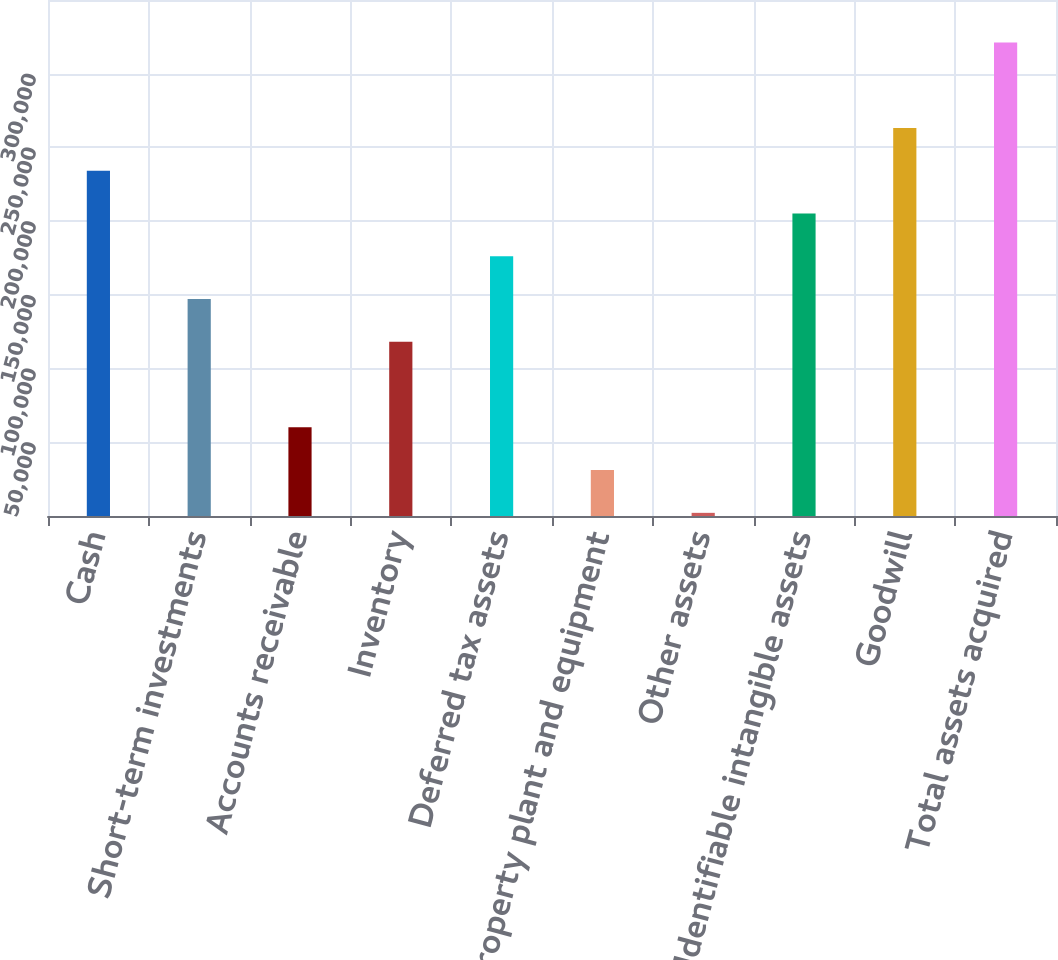Convert chart. <chart><loc_0><loc_0><loc_500><loc_500><bar_chart><fcel>Cash<fcel>Short-term investments<fcel>Accounts receivable<fcel>Inventory<fcel>Deferred tax assets<fcel>Property plant and equipment<fcel>Other assets<fcel>Identifiable intangible assets<fcel>Goodwill<fcel>Total assets acquired<nl><fcel>234177<fcel>147162<fcel>60148.4<fcel>118158<fcel>176167<fcel>31143.7<fcel>2139<fcel>205172<fcel>263181<fcel>321191<nl></chart> 